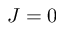<formula> <loc_0><loc_0><loc_500><loc_500>J = 0</formula> 